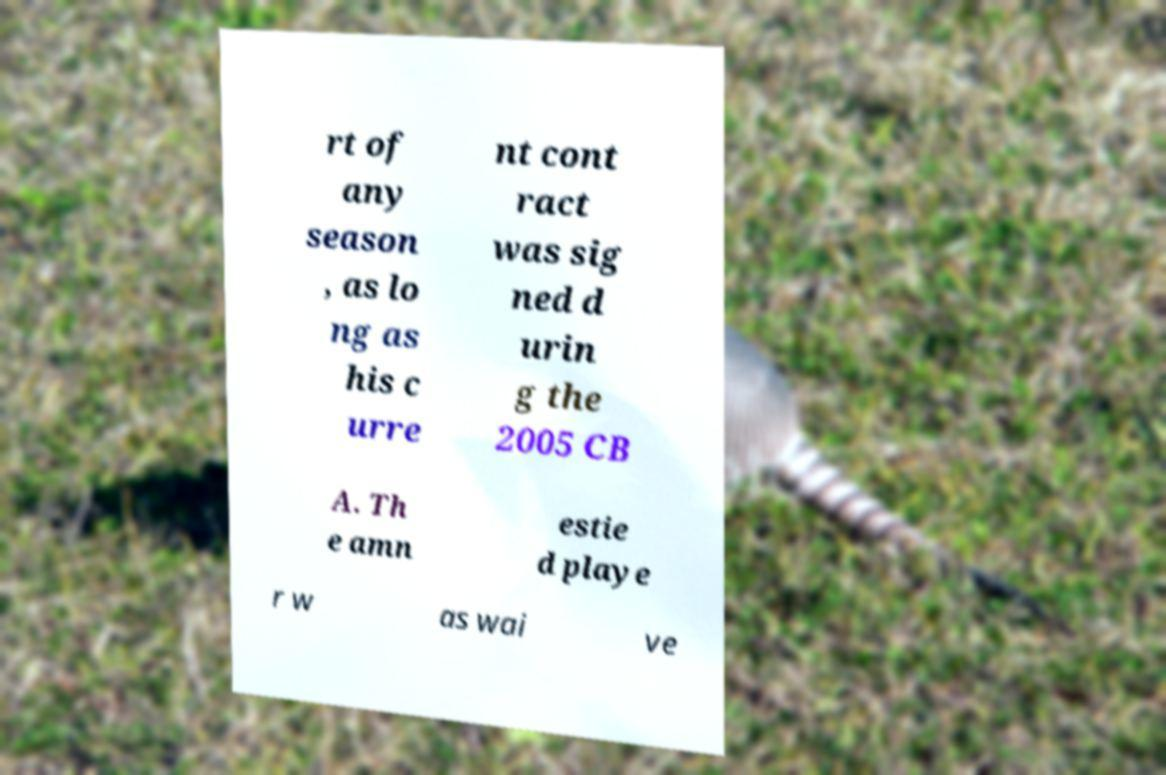There's text embedded in this image that I need extracted. Can you transcribe it verbatim? rt of any season , as lo ng as his c urre nt cont ract was sig ned d urin g the 2005 CB A. Th e amn estie d playe r w as wai ve 